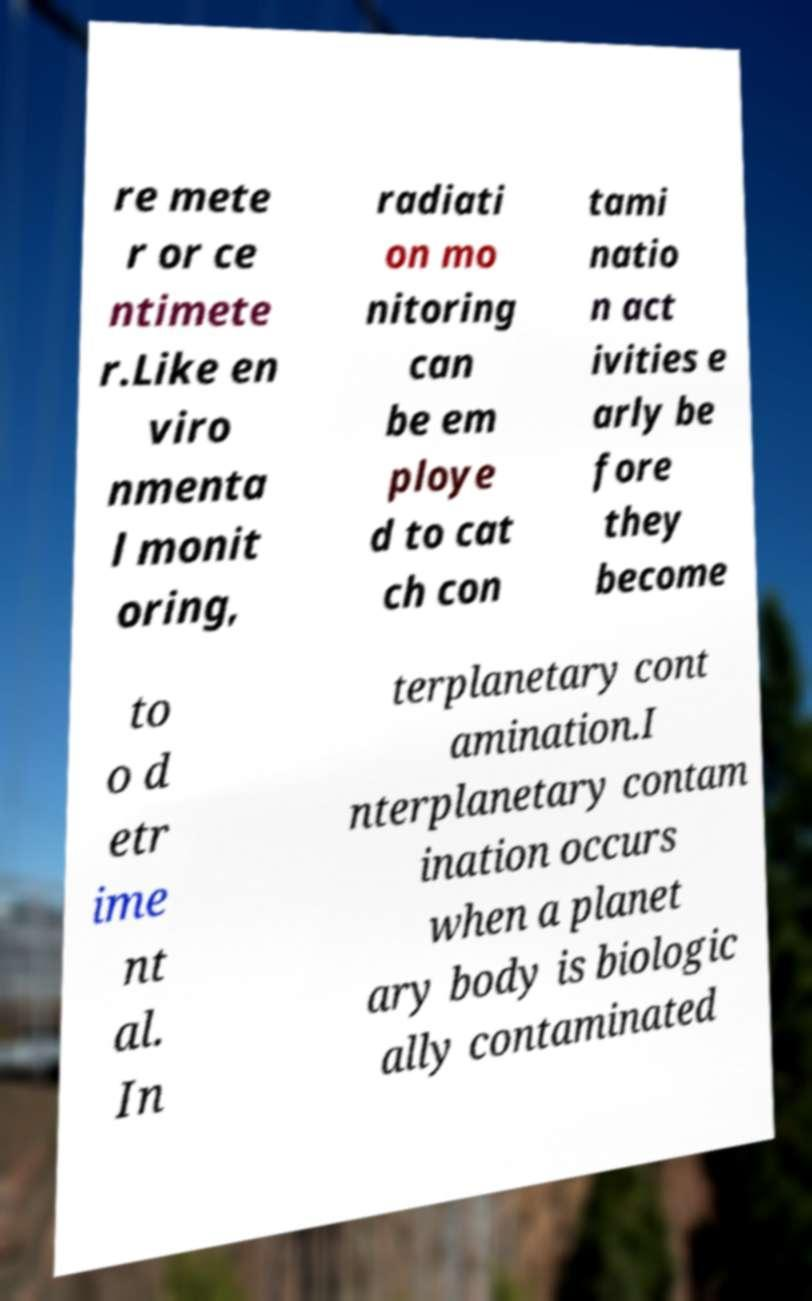There's text embedded in this image that I need extracted. Can you transcribe it verbatim? re mete r or ce ntimete r.Like en viro nmenta l monit oring, radiati on mo nitoring can be em ploye d to cat ch con tami natio n act ivities e arly be fore they become to o d etr ime nt al. In terplanetary cont amination.I nterplanetary contam ination occurs when a planet ary body is biologic ally contaminated 